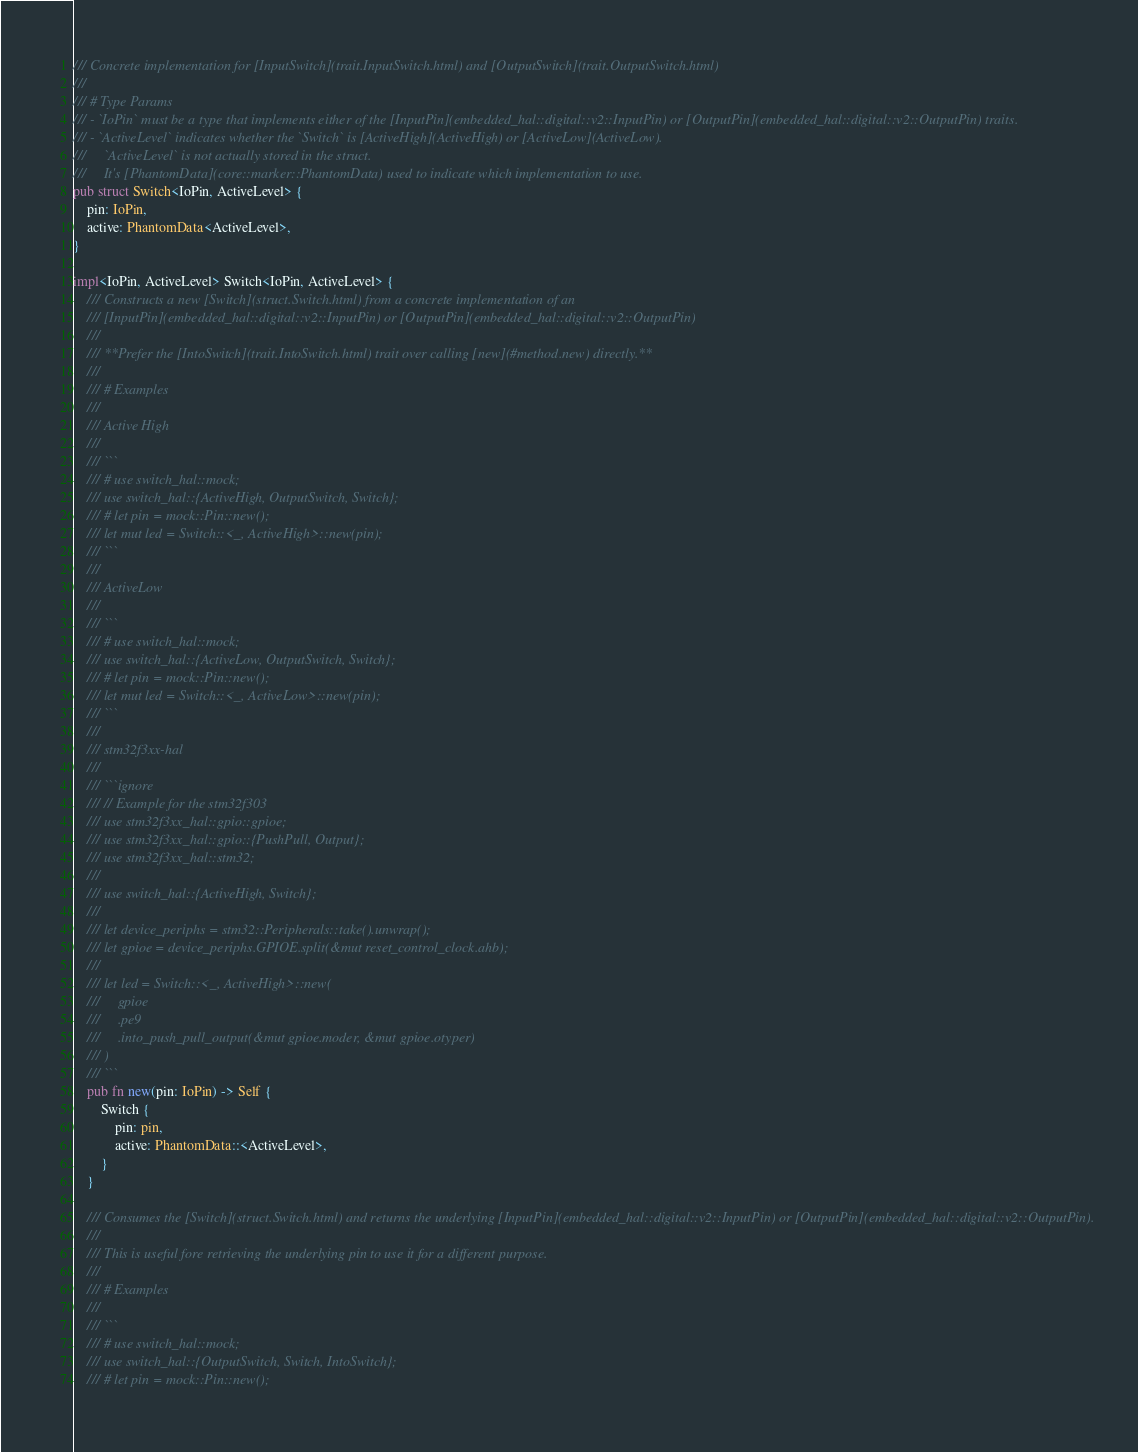<code> <loc_0><loc_0><loc_500><loc_500><_Rust_>/// Concrete implementation for [InputSwitch](trait.InputSwitch.html) and [OutputSwitch](trait.OutputSwitch.html)
///
/// # Type Params
/// - `IoPin` must be a type that implements either of the [InputPin](embedded_hal::digital::v2::InputPin) or [OutputPin](embedded_hal::digital::v2::OutputPin) traits.
/// - `ActiveLevel` indicates whether the `Switch` is [ActiveHigh](ActiveHigh) or [ActiveLow](ActiveLow).
///     `ActiveLevel` is not actually stored in the struct.
///     It's [PhantomData](core::marker::PhantomData) used to indicate which implementation to use.
pub struct Switch<IoPin, ActiveLevel> {
    pin: IoPin,
    active: PhantomData<ActiveLevel>,
}

impl<IoPin, ActiveLevel> Switch<IoPin, ActiveLevel> {
    /// Constructs a new [Switch](struct.Switch.html) from a concrete implementation of an
    /// [InputPin](embedded_hal::digital::v2::InputPin) or [OutputPin](embedded_hal::digital::v2::OutputPin)
    ///
    /// **Prefer the [IntoSwitch](trait.IntoSwitch.html) trait over calling [new](#method.new) directly.**
    ///
    /// # Examples
    ///
    /// Active High
    ///
    /// ```
    /// # use switch_hal::mock;
    /// use switch_hal::{ActiveHigh, OutputSwitch, Switch};
    /// # let pin = mock::Pin::new();
    /// let mut led = Switch::<_, ActiveHigh>::new(pin);
    /// ```
    ///
    /// ActiveLow
    ///
    /// ```
    /// # use switch_hal::mock;
    /// use switch_hal::{ActiveLow, OutputSwitch, Switch};
    /// # let pin = mock::Pin::new();
    /// let mut led = Switch::<_, ActiveLow>::new(pin);
    /// ```
    ///
    /// stm32f3xx-hal
    ///
    /// ```ignore
    /// // Example for the stm32f303
    /// use stm32f3xx_hal::gpio::gpioe;
    /// use stm32f3xx_hal::gpio::{PushPull, Output};
    /// use stm32f3xx_hal::stm32;
    ///
    /// use switch_hal::{ActiveHigh, Switch};
    ///
    /// let device_periphs = stm32::Peripherals::take().unwrap();
    /// let gpioe = device_periphs.GPIOE.split(&mut reset_control_clock.ahb);
    ///
    /// let led = Switch::<_, ActiveHigh>::new(
    ///     gpioe
    ///     .pe9
    ///     .into_push_pull_output(&mut gpioe.moder, &mut gpioe.otyper)
    /// )
    /// ```
    pub fn new(pin: IoPin) -> Self {
        Switch {
            pin: pin,
            active: PhantomData::<ActiveLevel>,
        }
    }

    /// Consumes the [Switch](struct.Switch.html) and returns the underlying [InputPin](embedded_hal::digital::v2::InputPin) or [OutputPin](embedded_hal::digital::v2::OutputPin).
    ///
    /// This is useful fore retrieving the underlying pin to use it for a different purpose.
    ///
    /// # Examples
    ///
    /// ```
    /// # use switch_hal::mock;
    /// use switch_hal::{OutputSwitch, Switch, IntoSwitch};
    /// # let pin = mock::Pin::new();</code> 